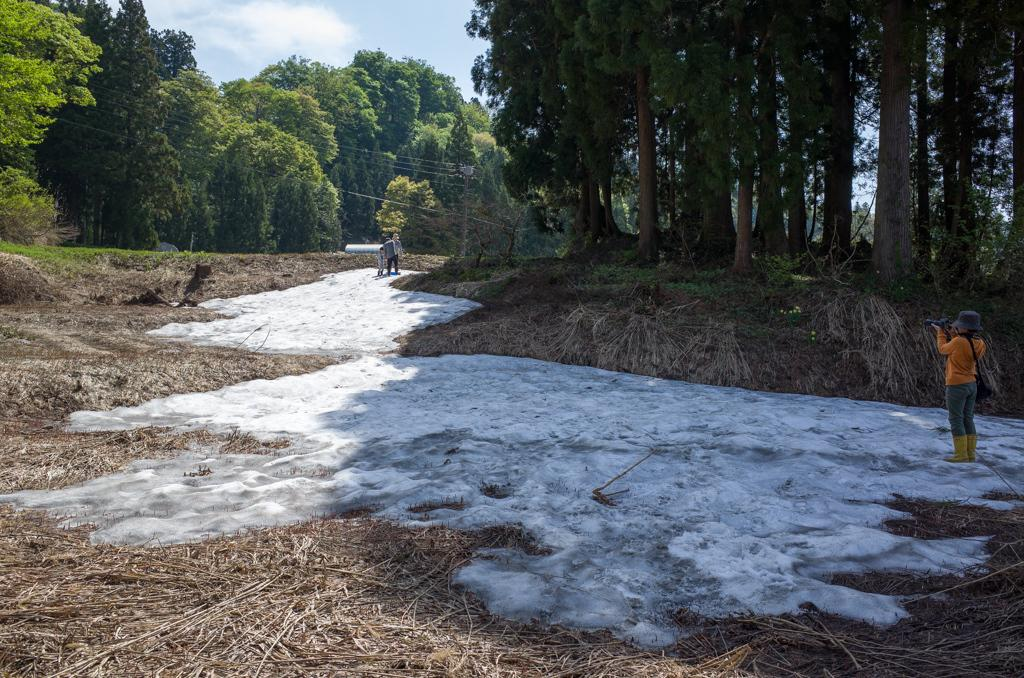What is the primary setting of the image? The primary setting of the image is outdoors, as there are people on the ground, trees, and grass visible. What type of vegetation can be seen in the image? Trees and grass are present in the image. What is visible in the background of the image? The sky is visible in the background of the image. What can be observed in the sky? Clouds are present in the sky. What type of glass is being used to reason with the people in the image? There is no glass or reasoning activity present in the image; it features people, trees, grass, and a sky with clouds. 